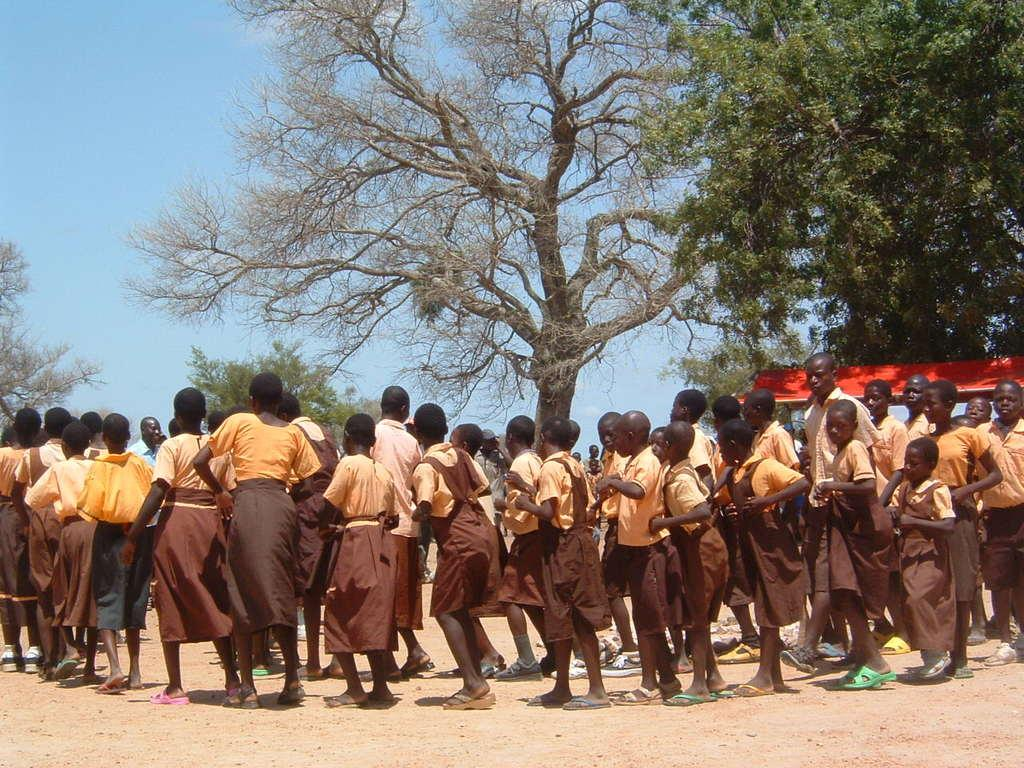What are the people in the image wearing? The people in the image are wearing uniforms. Where are the people located in the image? The people are on the sand. What can be seen in the background of the image? There are many trees and a red-colored roof for shelter in the background. What is visible in the sky in the image? The sky is visible in the image. What type of teeth can be seen in the image? There are no teeth visible in the image. Can you describe the crow that is perched on the red-colored roof in the image? There is no crow present in the image; it only features people with uniforms, sand, trees, a red-colored roof, and the sky. 